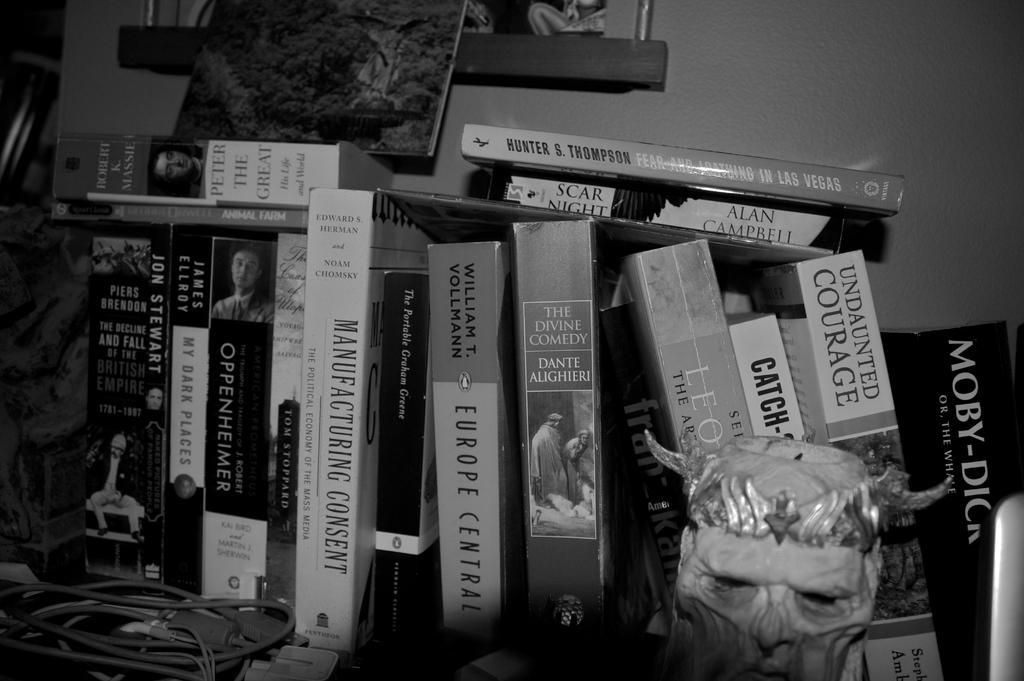Provide a one-sentence caption for the provided image. a black and white photo of a book collection that include the titles Europe Central, Scar Night, and MANUFACTURING CONSENT. 